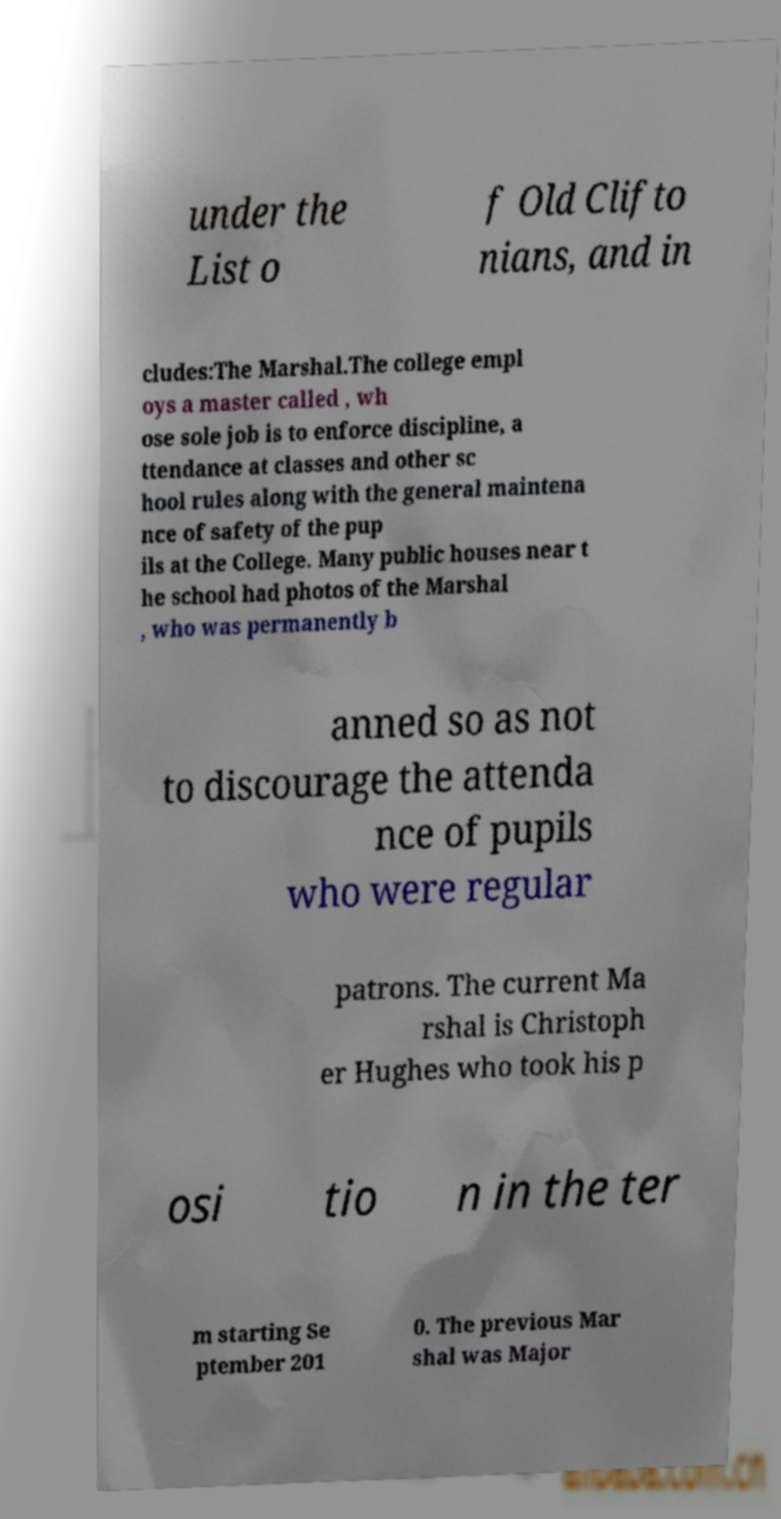Could you extract and type out the text from this image? under the List o f Old Clifto nians, and in cludes:The Marshal.The college empl oys a master called , wh ose sole job is to enforce discipline, a ttendance at classes and other sc hool rules along with the general maintena nce of safety of the pup ils at the College. Many public houses near t he school had photos of the Marshal , who was permanently b anned so as not to discourage the attenda nce of pupils who were regular patrons. The current Ma rshal is Christoph er Hughes who took his p osi tio n in the ter m starting Se ptember 201 0. The previous Mar shal was Major 